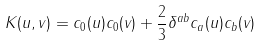Convert formula to latex. <formula><loc_0><loc_0><loc_500><loc_500>K ( u , v ) = c _ { 0 } ( u ) c _ { 0 } ( v ) + \frac { 2 } { 3 } \delta ^ { a b } c _ { a } ( u ) c _ { b } ( v )</formula> 